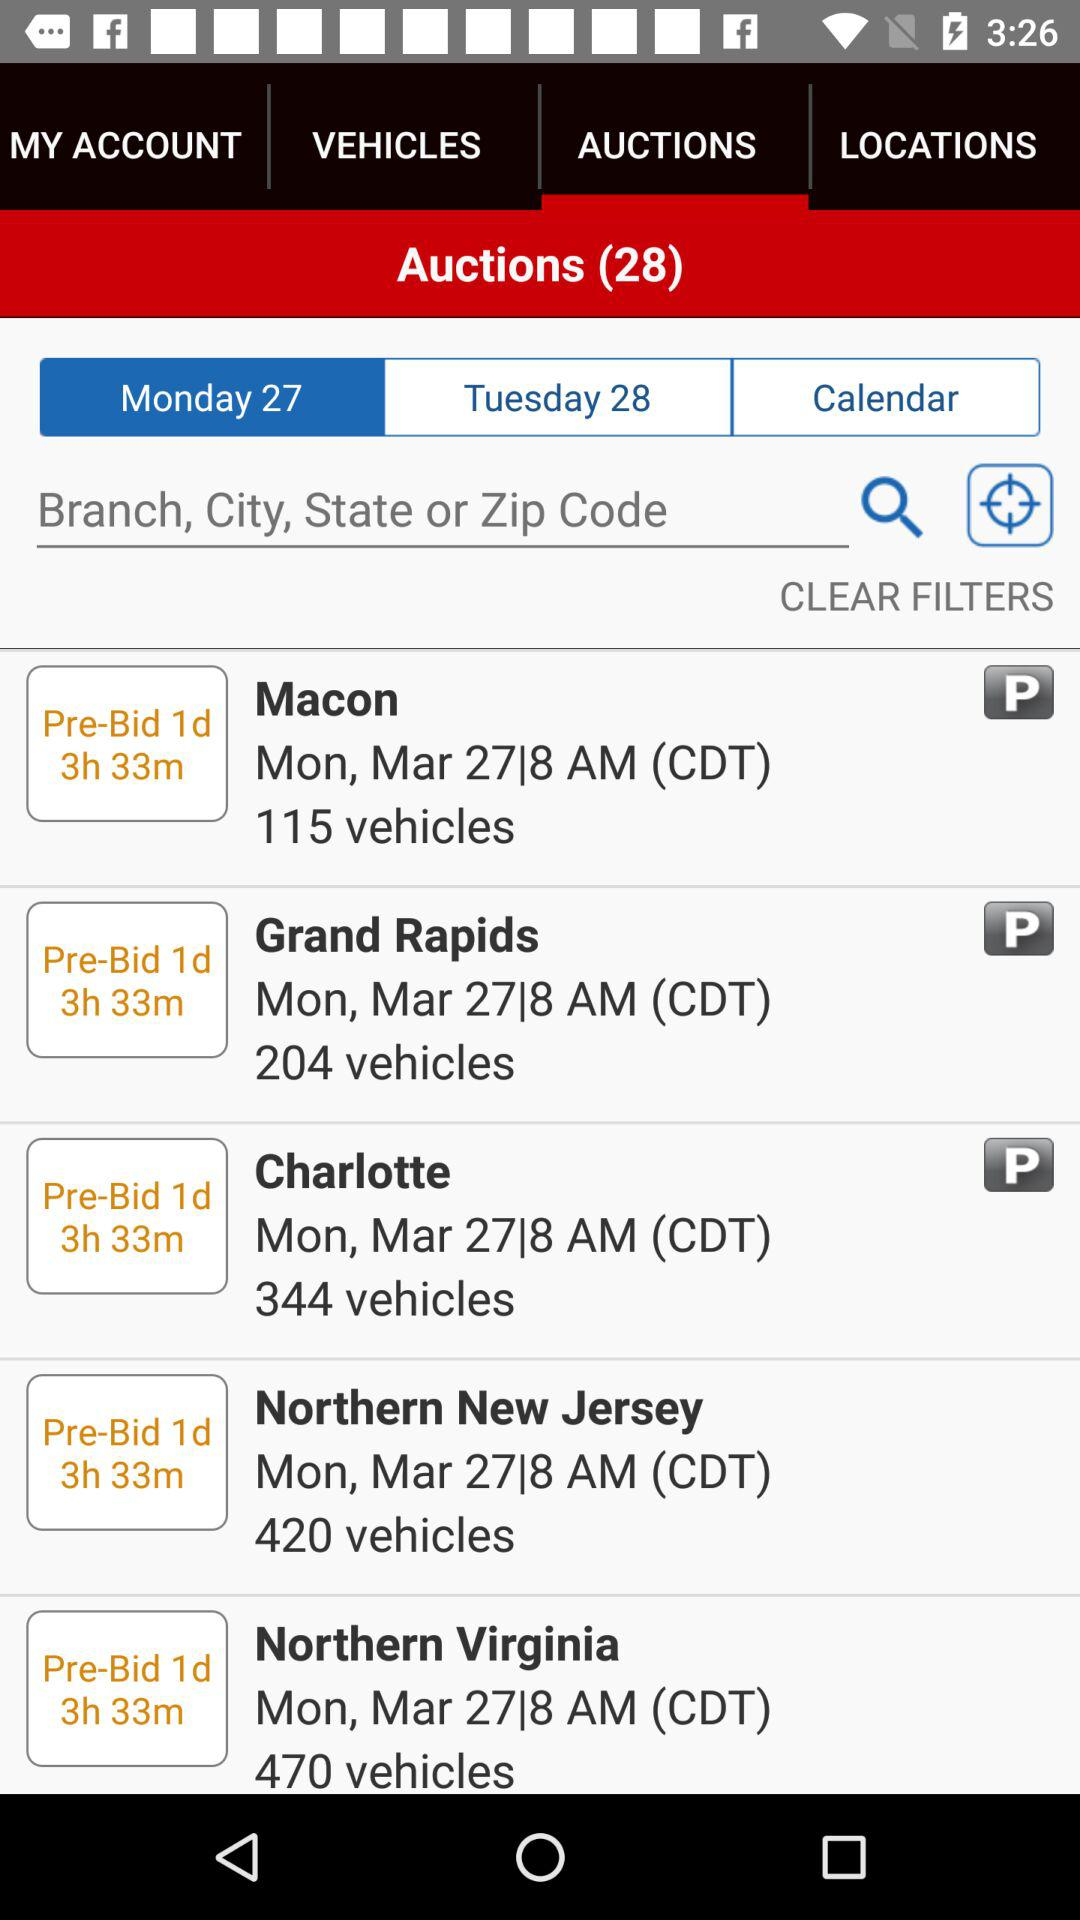How many more vehicles are in the Northern New Jersey auction than the Grand Rapids auction?
Answer the question using a single word or phrase. 216 